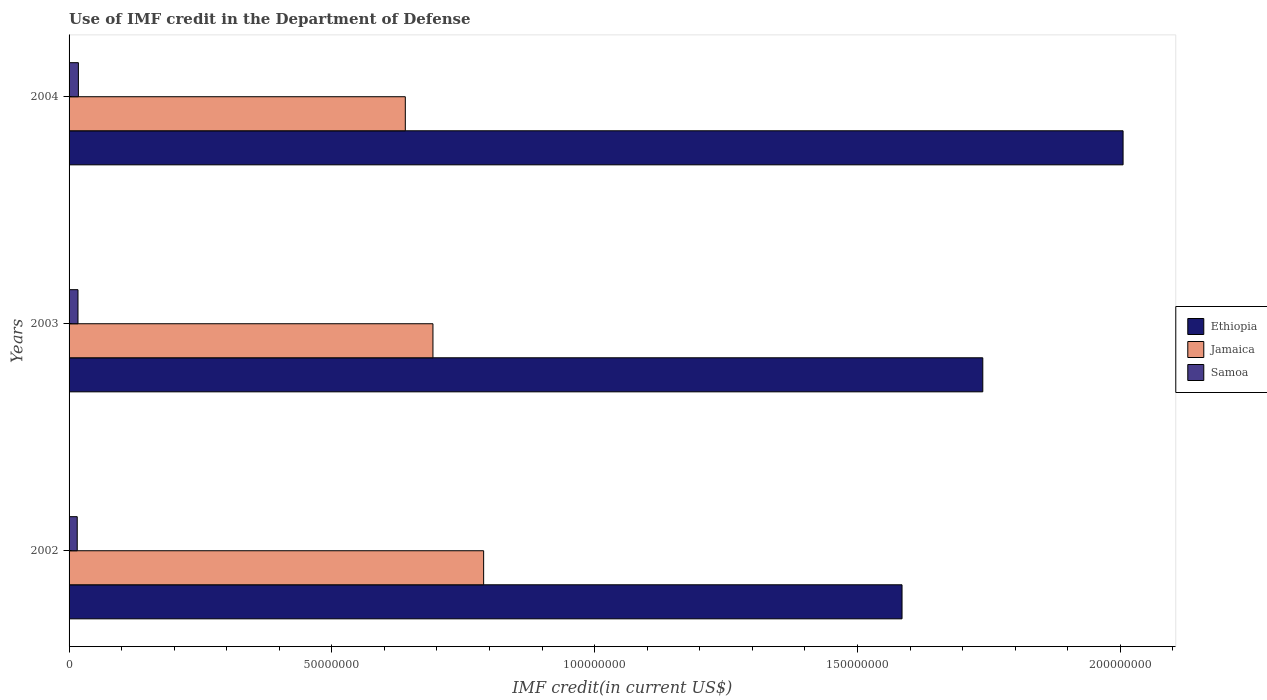How many different coloured bars are there?
Provide a succinct answer. 3. How many groups of bars are there?
Provide a succinct answer. 3. How many bars are there on the 3rd tick from the top?
Offer a very short reply. 3. What is the label of the 2nd group of bars from the top?
Give a very brief answer. 2003. In how many cases, is the number of bars for a given year not equal to the number of legend labels?
Give a very brief answer. 0. What is the IMF credit in the Department of Defense in Ethiopia in 2004?
Keep it short and to the point. 2.01e+08. Across all years, what is the maximum IMF credit in the Department of Defense in Ethiopia?
Keep it short and to the point. 2.01e+08. Across all years, what is the minimum IMF credit in the Department of Defense in Ethiopia?
Offer a terse response. 1.58e+08. What is the total IMF credit in the Department of Defense in Ethiopia in the graph?
Provide a short and direct response. 5.33e+08. What is the difference between the IMF credit in the Department of Defense in Ethiopia in 2002 and that in 2003?
Keep it short and to the point. -1.54e+07. What is the difference between the IMF credit in the Department of Defense in Samoa in 2004 and the IMF credit in the Department of Defense in Ethiopia in 2002?
Make the answer very short. -1.57e+08. What is the average IMF credit in the Department of Defense in Jamaica per year?
Make the answer very short. 7.07e+07. In the year 2003, what is the difference between the IMF credit in the Department of Defense in Jamaica and IMF credit in the Department of Defense in Ethiopia?
Your response must be concise. -1.05e+08. What is the ratio of the IMF credit in the Department of Defense in Samoa in 2002 to that in 2004?
Ensure brevity in your answer.  0.88. What is the difference between the highest and the second highest IMF credit in the Department of Defense in Jamaica?
Your answer should be compact. 9.64e+06. What is the difference between the highest and the lowest IMF credit in the Department of Defense in Ethiopia?
Make the answer very short. 4.21e+07. What does the 1st bar from the top in 2003 represents?
Your answer should be compact. Samoa. What does the 1st bar from the bottom in 2002 represents?
Provide a short and direct response. Ethiopia. How many bars are there?
Ensure brevity in your answer.  9. Are all the bars in the graph horizontal?
Keep it short and to the point. Yes. Are the values on the major ticks of X-axis written in scientific E-notation?
Your response must be concise. No. Where does the legend appear in the graph?
Offer a very short reply. Center right. How many legend labels are there?
Ensure brevity in your answer.  3. How are the legend labels stacked?
Offer a very short reply. Vertical. What is the title of the graph?
Your response must be concise. Use of IMF credit in the Department of Defense. What is the label or title of the X-axis?
Ensure brevity in your answer.  IMF credit(in current US$). What is the label or title of the Y-axis?
Your response must be concise. Years. What is the IMF credit(in current US$) in Ethiopia in 2002?
Offer a very short reply. 1.58e+08. What is the IMF credit(in current US$) in Jamaica in 2002?
Your answer should be very brief. 7.89e+07. What is the IMF credit(in current US$) of Samoa in 2002?
Offer a terse response. 1.55e+06. What is the IMF credit(in current US$) of Ethiopia in 2003?
Provide a succinct answer. 1.74e+08. What is the IMF credit(in current US$) in Jamaica in 2003?
Offer a terse response. 6.92e+07. What is the IMF credit(in current US$) of Samoa in 2003?
Offer a very short reply. 1.70e+06. What is the IMF credit(in current US$) in Ethiopia in 2004?
Keep it short and to the point. 2.01e+08. What is the IMF credit(in current US$) in Jamaica in 2004?
Your answer should be compact. 6.40e+07. What is the IMF credit(in current US$) of Samoa in 2004?
Make the answer very short. 1.77e+06. Across all years, what is the maximum IMF credit(in current US$) in Ethiopia?
Make the answer very short. 2.01e+08. Across all years, what is the maximum IMF credit(in current US$) in Jamaica?
Your answer should be compact. 7.89e+07. Across all years, what is the maximum IMF credit(in current US$) in Samoa?
Give a very brief answer. 1.77e+06. Across all years, what is the minimum IMF credit(in current US$) of Ethiopia?
Your response must be concise. 1.58e+08. Across all years, what is the minimum IMF credit(in current US$) of Jamaica?
Ensure brevity in your answer.  6.40e+07. Across all years, what is the minimum IMF credit(in current US$) in Samoa?
Your answer should be compact. 1.55e+06. What is the total IMF credit(in current US$) of Ethiopia in the graph?
Offer a very short reply. 5.33e+08. What is the total IMF credit(in current US$) in Jamaica in the graph?
Keep it short and to the point. 2.12e+08. What is the total IMF credit(in current US$) in Samoa in the graph?
Your answer should be compact. 5.02e+06. What is the difference between the IMF credit(in current US$) in Ethiopia in 2002 and that in 2003?
Offer a terse response. -1.54e+07. What is the difference between the IMF credit(in current US$) in Jamaica in 2002 and that in 2003?
Your response must be concise. 9.64e+06. What is the difference between the IMF credit(in current US$) in Samoa in 2002 and that in 2003?
Provide a succinct answer. -1.44e+05. What is the difference between the IMF credit(in current US$) in Ethiopia in 2002 and that in 2004?
Your answer should be very brief. -4.21e+07. What is the difference between the IMF credit(in current US$) of Jamaica in 2002 and that in 2004?
Give a very brief answer. 1.49e+07. What is the difference between the IMF credit(in current US$) in Samoa in 2002 and that in 2004?
Provide a short and direct response. -2.21e+05. What is the difference between the IMF credit(in current US$) of Ethiopia in 2003 and that in 2004?
Your response must be concise. -2.67e+07. What is the difference between the IMF credit(in current US$) in Jamaica in 2003 and that in 2004?
Give a very brief answer. 5.26e+06. What is the difference between the IMF credit(in current US$) in Samoa in 2003 and that in 2004?
Your answer should be very brief. -7.70e+04. What is the difference between the IMF credit(in current US$) of Ethiopia in 2002 and the IMF credit(in current US$) of Jamaica in 2003?
Offer a very short reply. 8.93e+07. What is the difference between the IMF credit(in current US$) in Ethiopia in 2002 and the IMF credit(in current US$) in Samoa in 2003?
Make the answer very short. 1.57e+08. What is the difference between the IMF credit(in current US$) of Jamaica in 2002 and the IMF credit(in current US$) of Samoa in 2003?
Your response must be concise. 7.72e+07. What is the difference between the IMF credit(in current US$) in Ethiopia in 2002 and the IMF credit(in current US$) in Jamaica in 2004?
Provide a short and direct response. 9.45e+07. What is the difference between the IMF credit(in current US$) in Ethiopia in 2002 and the IMF credit(in current US$) in Samoa in 2004?
Provide a short and direct response. 1.57e+08. What is the difference between the IMF credit(in current US$) in Jamaica in 2002 and the IMF credit(in current US$) in Samoa in 2004?
Ensure brevity in your answer.  7.71e+07. What is the difference between the IMF credit(in current US$) of Ethiopia in 2003 and the IMF credit(in current US$) of Jamaica in 2004?
Your answer should be very brief. 1.10e+08. What is the difference between the IMF credit(in current US$) of Ethiopia in 2003 and the IMF credit(in current US$) of Samoa in 2004?
Your answer should be compact. 1.72e+08. What is the difference between the IMF credit(in current US$) in Jamaica in 2003 and the IMF credit(in current US$) in Samoa in 2004?
Make the answer very short. 6.75e+07. What is the average IMF credit(in current US$) of Ethiopia per year?
Ensure brevity in your answer.  1.78e+08. What is the average IMF credit(in current US$) in Jamaica per year?
Your answer should be very brief. 7.07e+07. What is the average IMF credit(in current US$) of Samoa per year?
Keep it short and to the point. 1.67e+06. In the year 2002, what is the difference between the IMF credit(in current US$) of Ethiopia and IMF credit(in current US$) of Jamaica?
Your answer should be very brief. 7.96e+07. In the year 2002, what is the difference between the IMF credit(in current US$) in Ethiopia and IMF credit(in current US$) in Samoa?
Your answer should be compact. 1.57e+08. In the year 2002, what is the difference between the IMF credit(in current US$) in Jamaica and IMF credit(in current US$) in Samoa?
Your response must be concise. 7.73e+07. In the year 2003, what is the difference between the IMF credit(in current US$) of Ethiopia and IMF credit(in current US$) of Jamaica?
Your answer should be compact. 1.05e+08. In the year 2003, what is the difference between the IMF credit(in current US$) of Ethiopia and IMF credit(in current US$) of Samoa?
Provide a succinct answer. 1.72e+08. In the year 2003, what is the difference between the IMF credit(in current US$) in Jamaica and IMF credit(in current US$) in Samoa?
Provide a succinct answer. 6.75e+07. In the year 2004, what is the difference between the IMF credit(in current US$) in Ethiopia and IMF credit(in current US$) in Jamaica?
Keep it short and to the point. 1.37e+08. In the year 2004, what is the difference between the IMF credit(in current US$) of Ethiopia and IMF credit(in current US$) of Samoa?
Make the answer very short. 1.99e+08. In the year 2004, what is the difference between the IMF credit(in current US$) in Jamaica and IMF credit(in current US$) in Samoa?
Your answer should be compact. 6.22e+07. What is the ratio of the IMF credit(in current US$) in Ethiopia in 2002 to that in 2003?
Your answer should be compact. 0.91. What is the ratio of the IMF credit(in current US$) in Jamaica in 2002 to that in 2003?
Your answer should be compact. 1.14. What is the ratio of the IMF credit(in current US$) in Samoa in 2002 to that in 2003?
Provide a succinct answer. 0.92. What is the ratio of the IMF credit(in current US$) in Ethiopia in 2002 to that in 2004?
Make the answer very short. 0.79. What is the ratio of the IMF credit(in current US$) of Jamaica in 2002 to that in 2004?
Provide a succinct answer. 1.23. What is the ratio of the IMF credit(in current US$) of Samoa in 2002 to that in 2004?
Your response must be concise. 0.88. What is the ratio of the IMF credit(in current US$) of Ethiopia in 2003 to that in 2004?
Provide a succinct answer. 0.87. What is the ratio of the IMF credit(in current US$) of Jamaica in 2003 to that in 2004?
Your answer should be very brief. 1.08. What is the ratio of the IMF credit(in current US$) of Samoa in 2003 to that in 2004?
Keep it short and to the point. 0.96. What is the difference between the highest and the second highest IMF credit(in current US$) in Ethiopia?
Provide a short and direct response. 2.67e+07. What is the difference between the highest and the second highest IMF credit(in current US$) of Jamaica?
Provide a succinct answer. 9.64e+06. What is the difference between the highest and the second highest IMF credit(in current US$) of Samoa?
Your response must be concise. 7.70e+04. What is the difference between the highest and the lowest IMF credit(in current US$) of Ethiopia?
Your response must be concise. 4.21e+07. What is the difference between the highest and the lowest IMF credit(in current US$) in Jamaica?
Offer a very short reply. 1.49e+07. What is the difference between the highest and the lowest IMF credit(in current US$) of Samoa?
Give a very brief answer. 2.21e+05. 